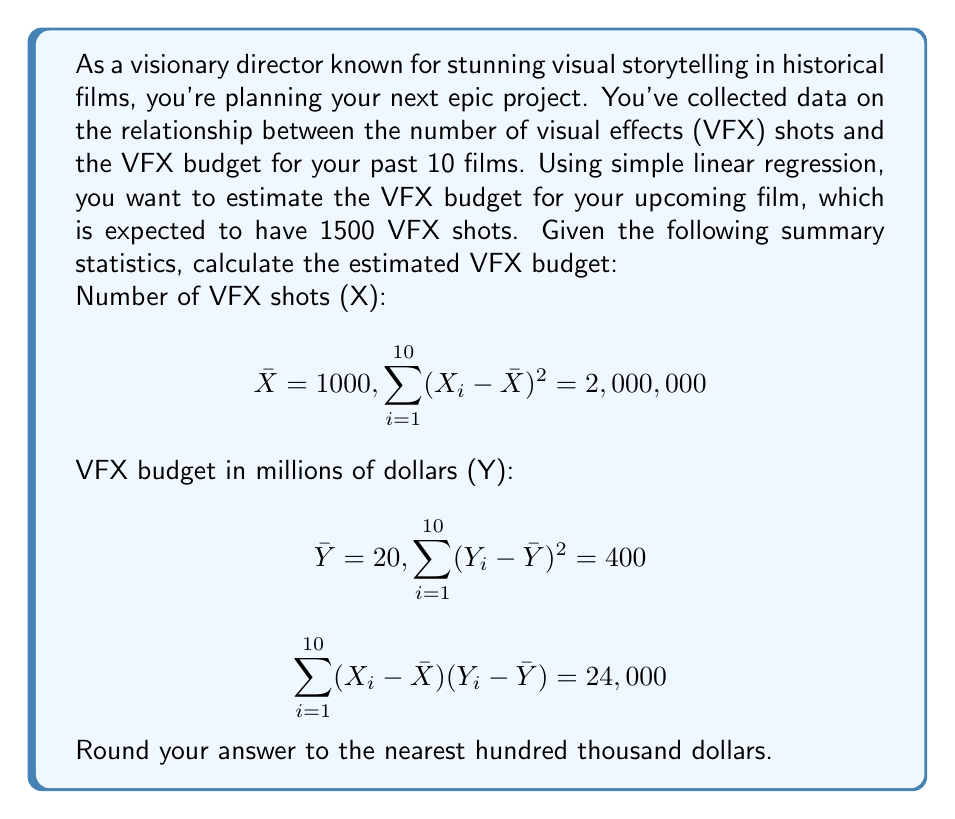What is the answer to this math problem? To solve this problem, we'll use simple linear regression to estimate the VFX budget based on the number of VFX shots. Let's follow these steps:

1. Calculate the slope (b) of the regression line:
   $$b = \frac{\sum_{i=1}^{10} (X_i - \bar{X})(Y_i - \bar{Y})}{\sum_{i=1}^{10} (X_i - \bar{X})^2}$$
   $$b = \frac{24,000}{2,000,000} = 0.012$$

2. Calculate the y-intercept (a) using the equation $\bar{Y} = a + b\bar{X}$:
   $$20 = a + 0.012 \times 1000$$
   $$a = 20 - 12 = 8$$

3. The regression equation is:
   $$Y = 8 + 0.012X$$

4. To estimate the VFX budget for 1500 VFX shots, substitute X = 1500:
   $$Y = 8 + 0.012 \times 1500 = 8 + 18 = 26$$

Therefore, the estimated VFX budget for a film with 1500 VFX shots is $26 million.
Answer: $26,000,000 